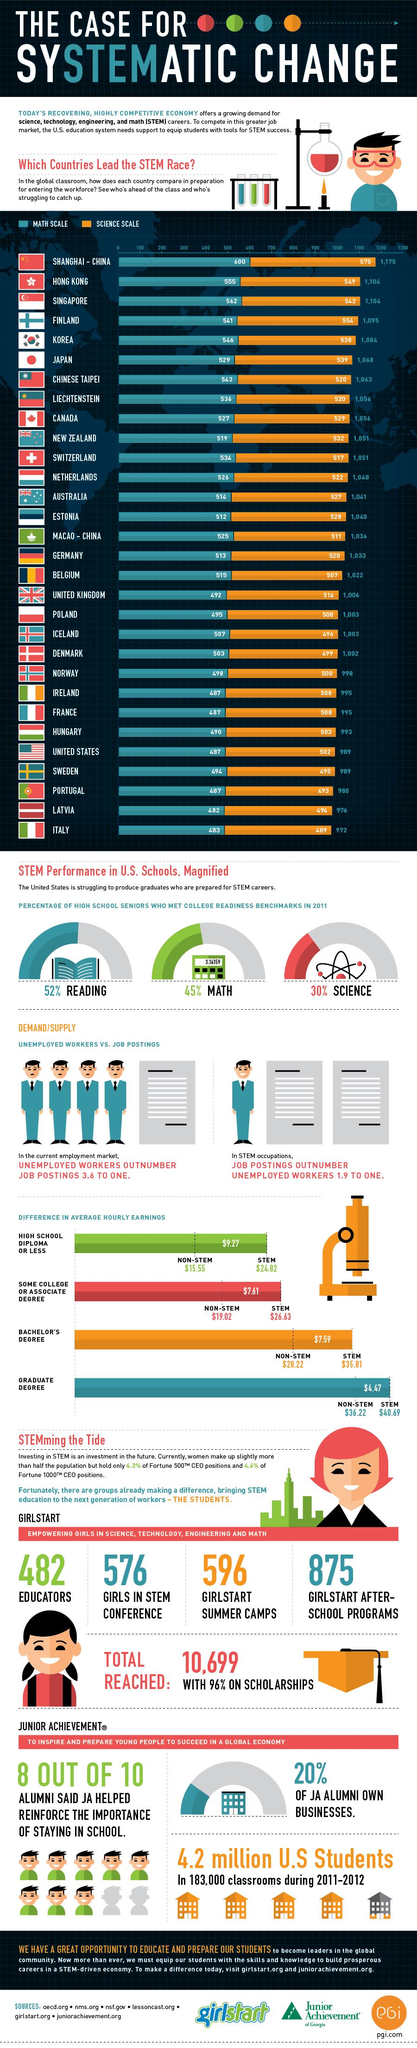Draw attention to some important aspects in this diagram. South Korea has a Math scale of 546 and a Science scale of 538, making it one of the top performing countries in both subjects. There are 875 girl-only after-school programs for STEM. Nine countries have a scale in Math and Science that is less than 1000. Approximately 70% of high school seniors do not meet the college readiness standards for Science. There are six countries with a rating less than 500 in science. 